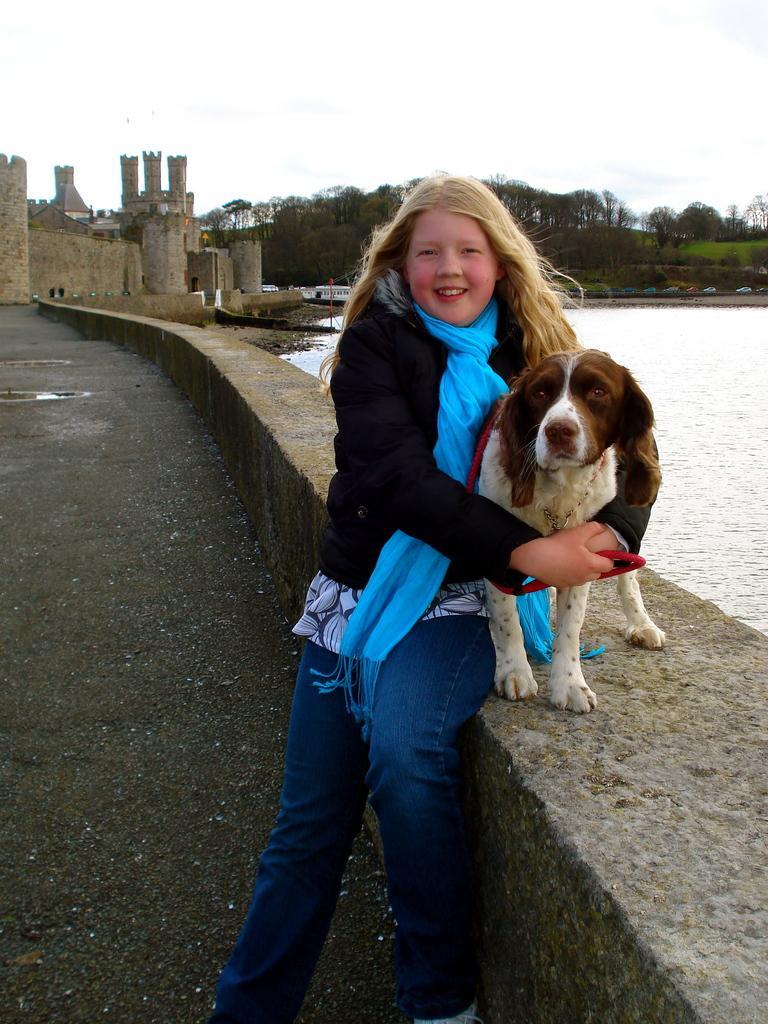In one or two sentences, can you explain what this image depicts? In this picture we can see a person who is holding a dog with her hands. This is road. Here we can see water. On the background we can see some trees. And these are the buildings. And there is sky. 